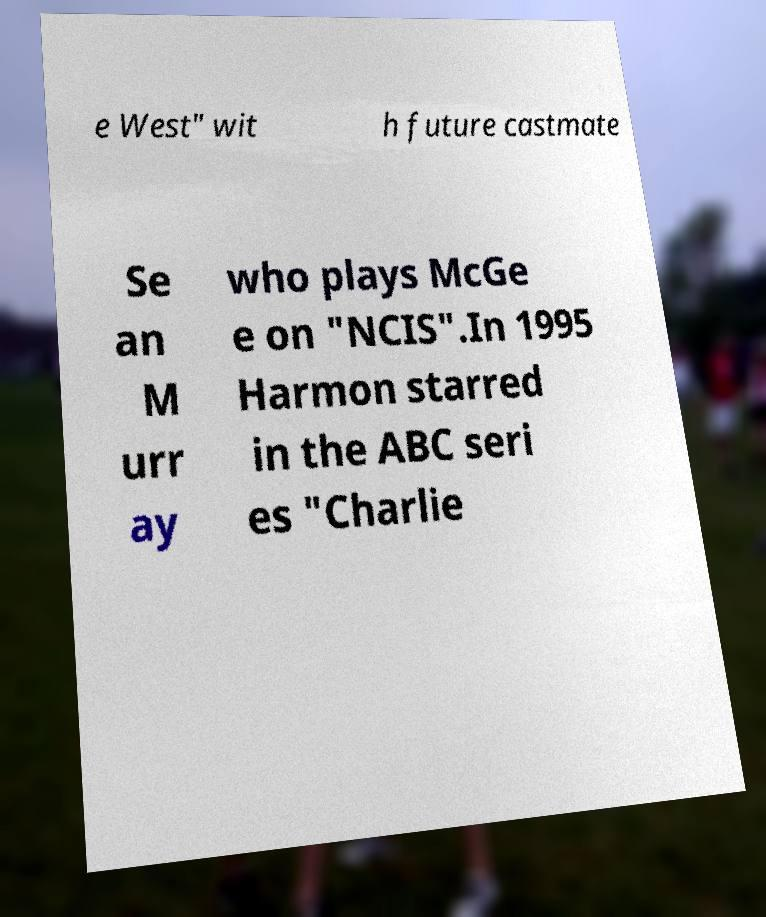I need the written content from this picture converted into text. Can you do that? e West" wit h future castmate Se an M urr ay who plays McGe e on "NCIS".In 1995 Harmon starred in the ABC seri es "Charlie 